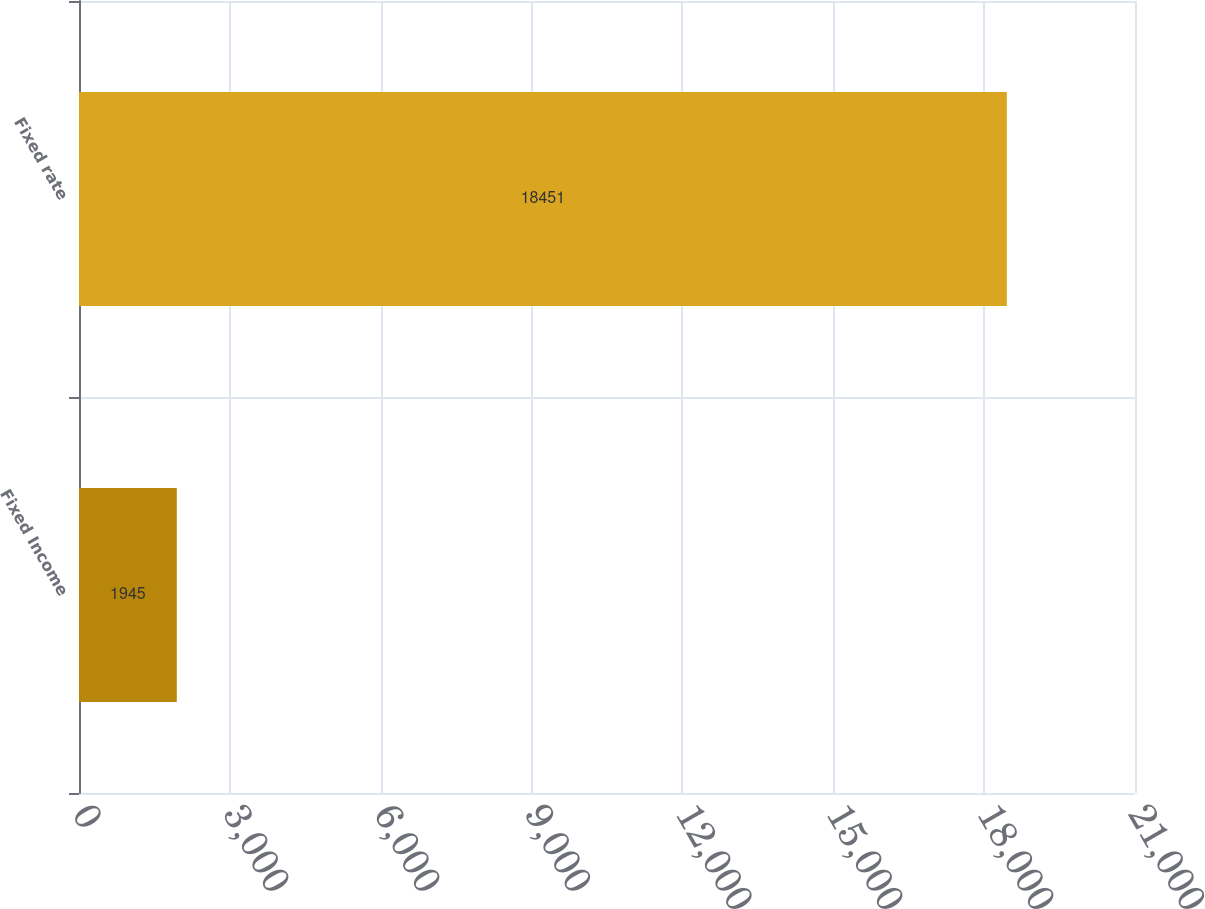<chart> <loc_0><loc_0><loc_500><loc_500><bar_chart><fcel>Fixed Income<fcel>Fixed rate<nl><fcel>1945<fcel>18451<nl></chart> 